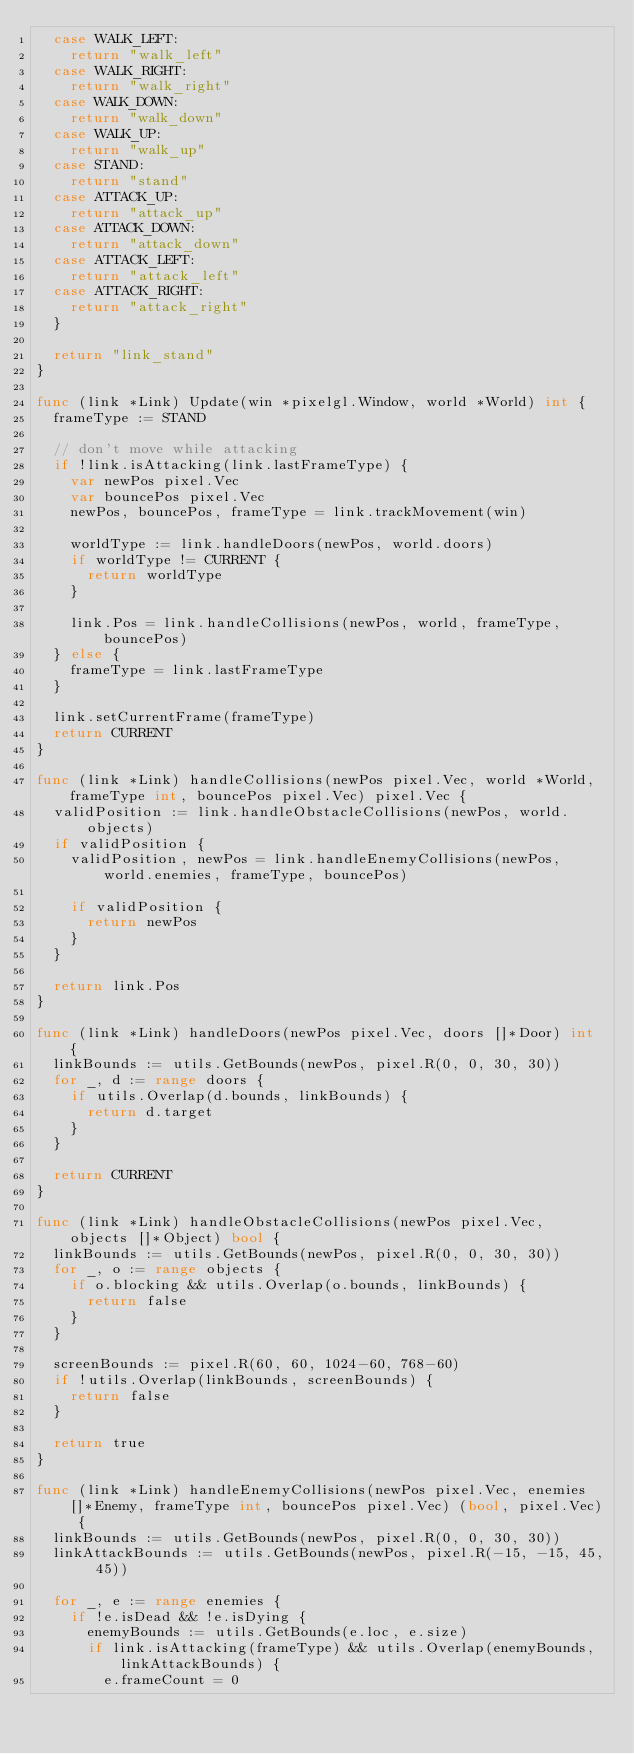Convert code to text. <code><loc_0><loc_0><loc_500><loc_500><_Go_>	case WALK_LEFT:
		return "walk_left"
	case WALK_RIGHT:
		return "walk_right"
	case WALK_DOWN:
		return "walk_down"
	case WALK_UP:
		return "walk_up"
	case STAND:
		return "stand"
	case ATTACK_UP:
		return "attack_up"
	case ATTACK_DOWN:
		return "attack_down"
	case ATTACK_LEFT:
		return "attack_left"
	case ATTACK_RIGHT:
		return "attack_right"
	}

	return "link_stand"
}

func (link *Link) Update(win *pixelgl.Window, world *World) int {
	frameType := STAND

	// don't move while attacking
	if !link.isAttacking(link.lastFrameType) {
		var newPos pixel.Vec
		var bouncePos pixel.Vec
		newPos, bouncePos, frameType = link.trackMovement(win)

		worldType := link.handleDoors(newPos, world.doors)
		if worldType != CURRENT {
			return worldType
		}

		link.Pos = link.handleCollisions(newPos, world, frameType, bouncePos)
	} else {
		frameType = link.lastFrameType
	}

	link.setCurrentFrame(frameType)
	return CURRENT
}

func (link *Link) handleCollisions(newPos pixel.Vec, world *World, frameType int, bouncePos pixel.Vec) pixel.Vec {
	validPosition := link.handleObstacleCollisions(newPos, world.objects)
	if validPosition {
		validPosition, newPos = link.handleEnemyCollisions(newPos, world.enemies, frameType, bouncePos)

		if validPosition {
			return newPos
		}
	}

	return link.Pos
}

func (link *Link) handleDoors(newPos pixel.Vec, doors []*Door) int {
	linkBounds := utils.GetBounds(newPos, pixel.R(0, 0, 30, 30))
	for _, d := range doors {
		if utils.Overlap(d.bounds, linkBounds) {
			return d.target
		}
	}

	return CURRENT
}

func (link *Link) handleObstacleCollisions(newPos pixel.Vec, objects []*Object) bool {
	linkBounds := utils.GetBounds(newPos, pixel.R(0, 0, 30, 30))
	for _, o := range objects {
		if o.blocking && utils.Overlap(o.bounds, linkBounds) {
			return false
		}
	}

	screenBounds := pixel.R(60, 60, 1024-60, 768-60)
	if !utils.Overlap(linkBounds, screenBounds) {
		return false
	}

	return true
}

func (link *Link) handleEnemyCollisions(newPos pixel.Vec, enemies []*Enemy, frameType int, bouncePos pixel.Vec) (bool, pixel.Vec) {
	linkBounds := utils.GetBounds(newPos, pixel.R(0, 0, 30, 30))
	linkAttackBounds := utils.GetBounds(newPos, pixel.R(-15, -15, 45, 45))

	for _, e := range enemies {
		if !e.isDead && !e.isDying {
			enemyBounds := utils.GetBounds(e.loc, e.size)
			if link.isAttacking(frameType) && utils.Overlap(enemyBounds, linkAttackBounds) {
				e.frameCount = 0</code> 